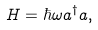<formula> <loc_0><loc_0><loc_500><loc_500>H = \hbar { \omega } a ^ { \dagger } a ,</formula> 